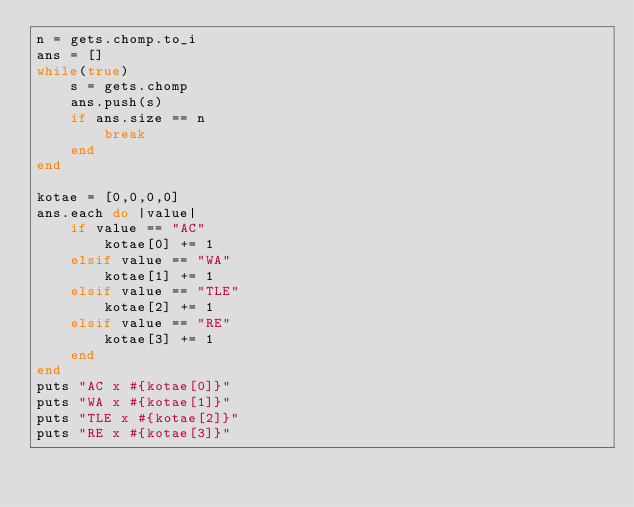<code> <loc_0><loc_0><loc_500><loc_500><_Ruby_>n = gets.chomp.to_i
ans = []
while(true)
    s = gets.chomp
    ans.push(s)
    if ans.size == n
        break
    end
end

kotae = [0,0,0,0]
ans.each do |value|
    if value == "AC"
        kotae[0] += 1
    elsif value == "WA"
        kotae[1] += 1
    elsif value == "TLE"
        kotae[2] += 1
    elsif value == "RE"
        kotae[3] += 1
    end
end
puts "AC x #{kotae[0]}"
puts "WA x #{kotae[1]}"
puts "TLE x #{kotae[2]}"
puts "RE x #{kotae[3]}"</code> 